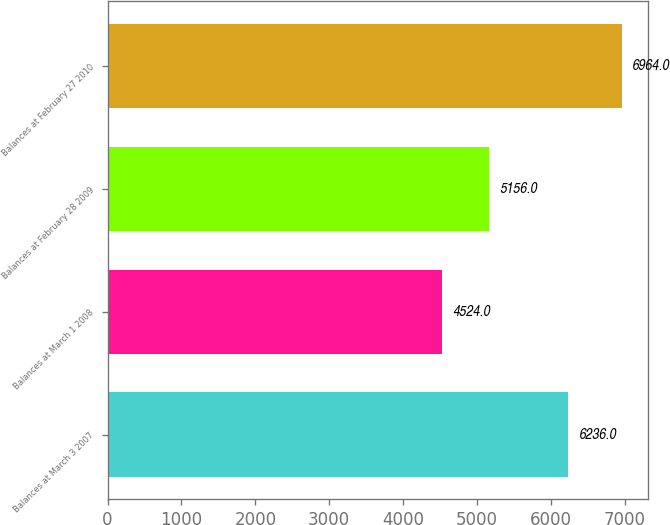Convert chart. <chart><loc_0><loc_0><loc_500><loc_500><bar_chart><fcel>Balances at March 3 2007<fcel>Balances at March 1 2008<fcel>Balances at February 28 2009<fcel>Balances at February 27 2010<nl><fcel>6236<fcel>4524<fcel>5156<fcel>6964<nl></chart> 